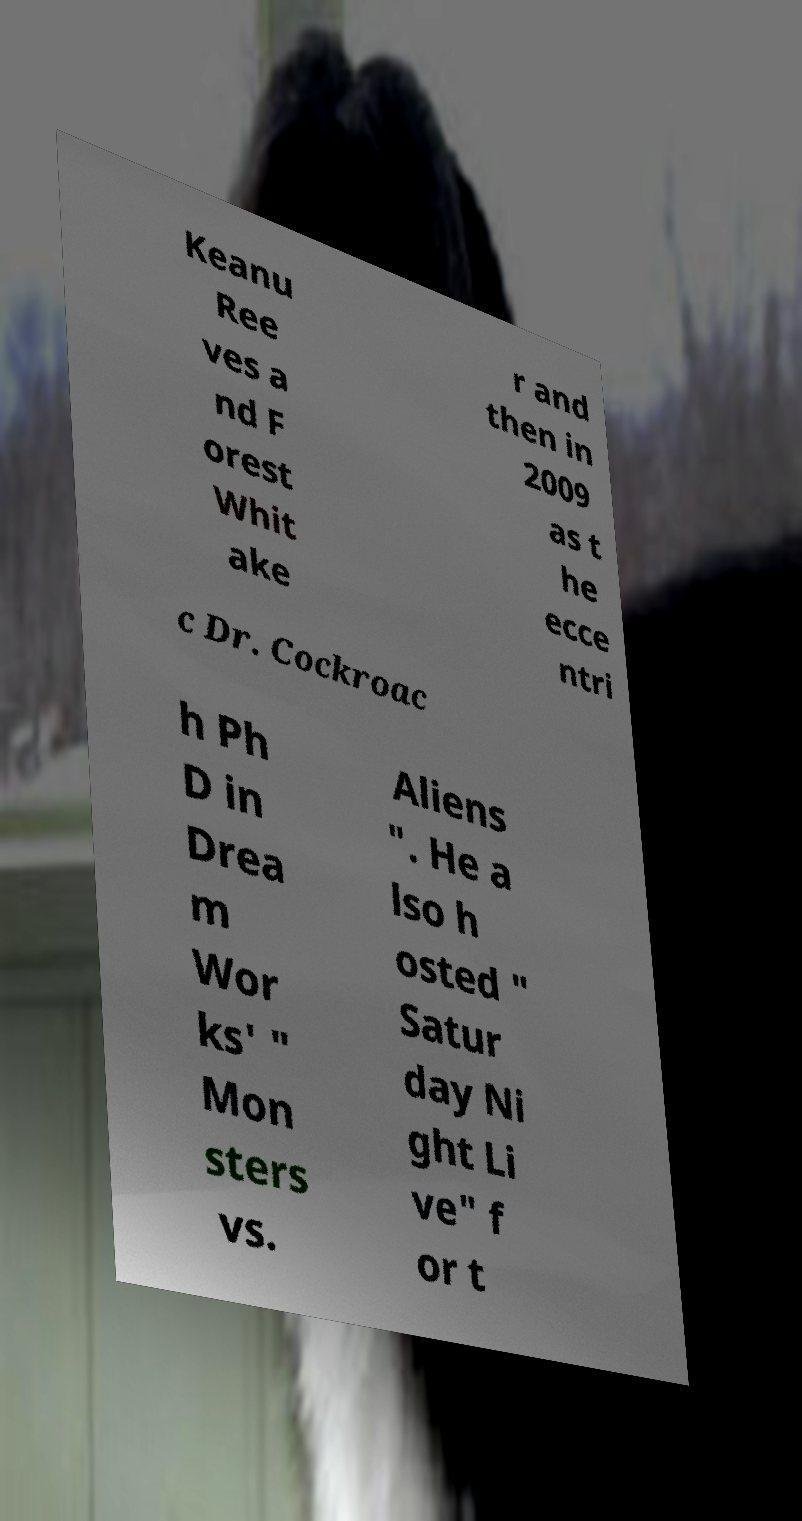Please read and relay the text visible in this image. What does it say? Keanu Ree ves a nd F orest Whit ake r and then in 2009 as t he ecce ntri c Dr. Cockroac h Ph D in Drea m Wor ks' " Mon sters vs. Aliens ". He a lso h osted " Satur day Ni ght Li ve" f or t 